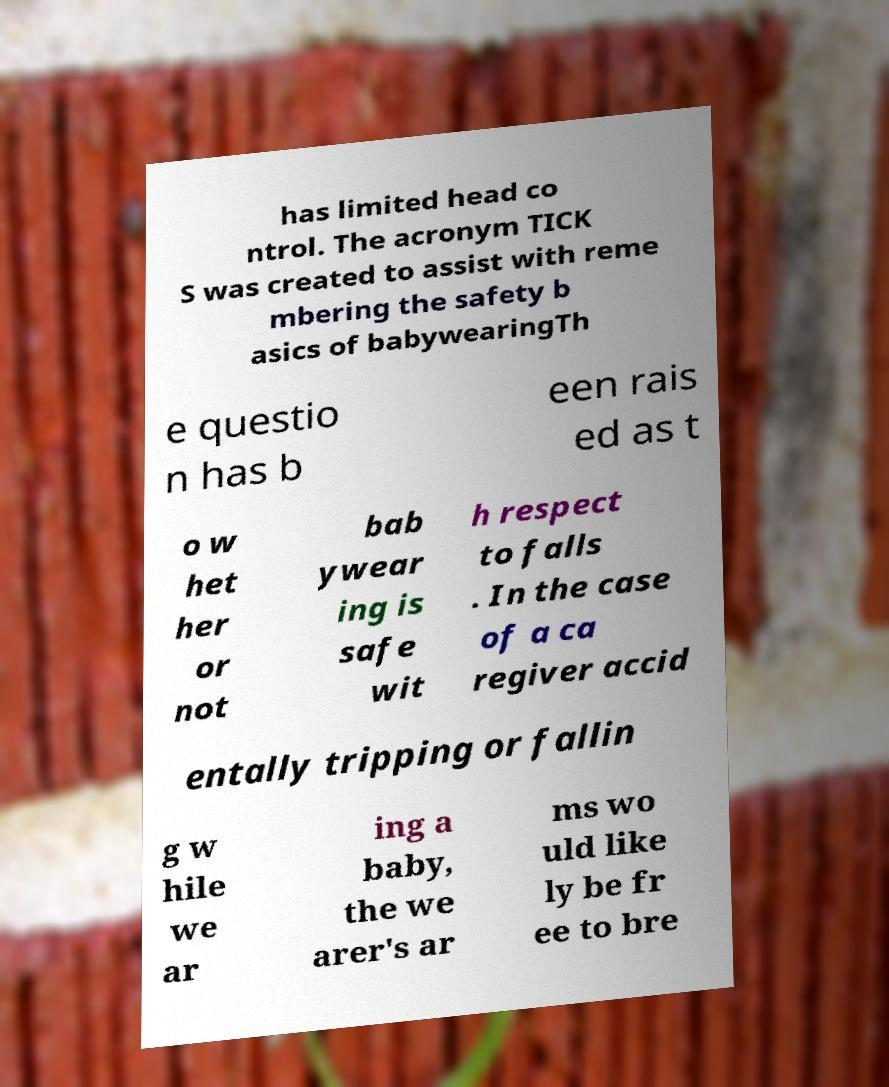Could you extract and type out the text from this image? has limited head co ntrol. The acronym TICK S was created to assist with reme mbering the safety b asics of babywearingTh e questio n has b een rais ed as t o w het her or not bab ywear ing is safe wit h respect to falls . In the case of a ca regiver accid entally tripping or fallin g w hile we ar ing a baby, the we arer's ar ms wo uld like ly be fr ee to bre 